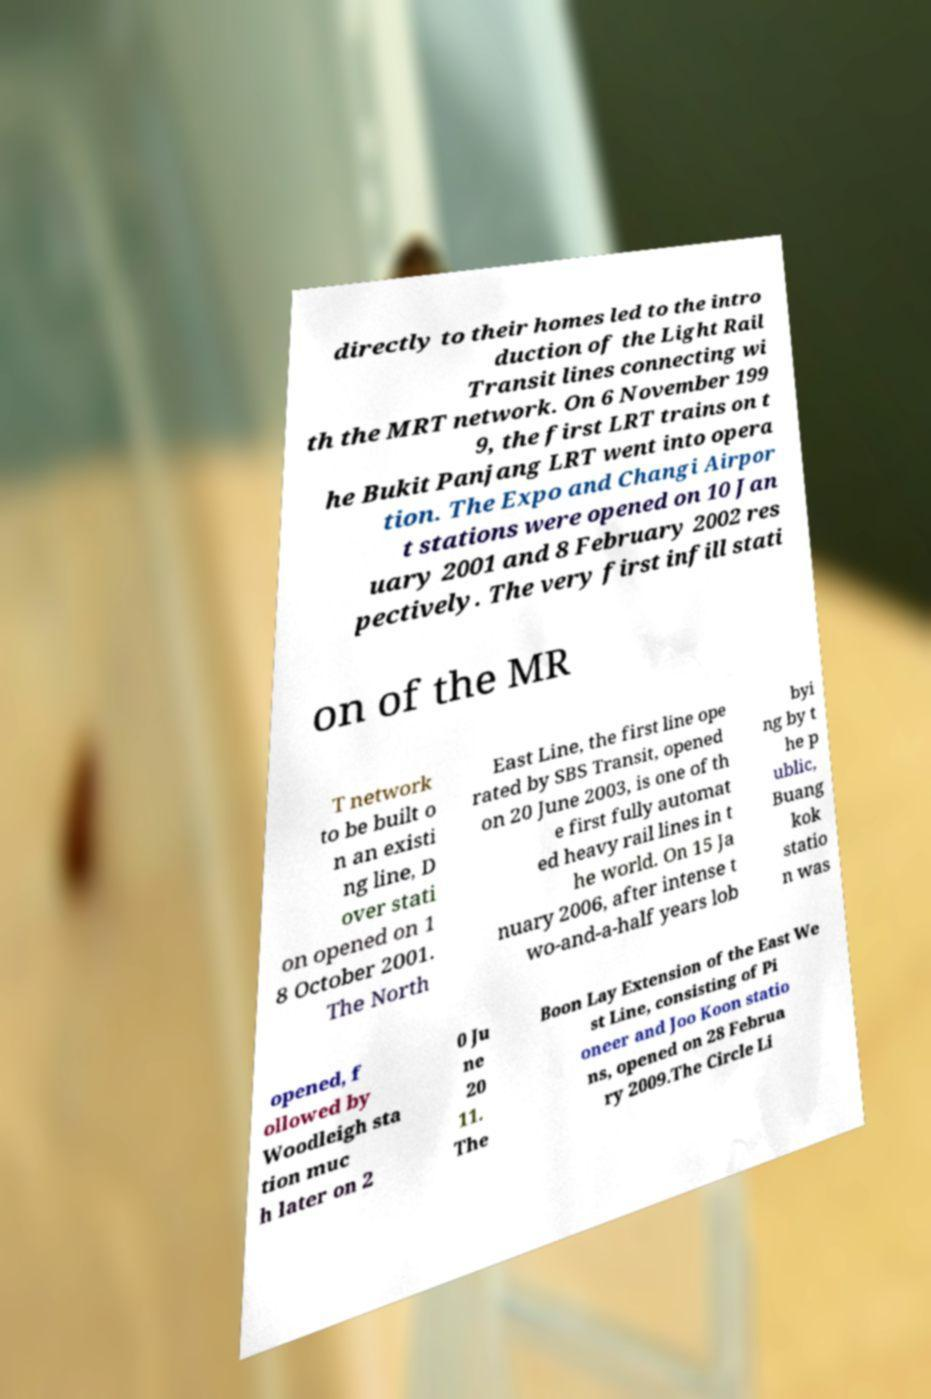I need the written content from this picture converted into text. Can you do that? directly to their homes led to the intro duction of the Light Rail Transit lines connecting wi th the MRT network. On 6 November 199 9, the first LRT trains on t he Bukit Panjang LRT went into opera tion. The Expo and Changi Airpor t stations were opened on 10 Jan uary 2001 and 8 February 2002 res pectively. The very first infill stati on of the MR T network to be built o n an existi ng line, D over stati on opened on 1 8 October 2001. The North East Line, the first line ope rated by SBS Transit, opened on 20 June 2003, is one of th e first fully automat ed heavy rail lines in t he world. On 15 Ja nuary 2006, after intense t wo-and-a-half years lob byi ng by t he p ublic, Buang kok statio n was opened, f ollowed by Woodleigh sta tion muc h later on 2 0 Ju ne 20 11. The Boon Lay Extension of the East We st Line, consisting of Pi oneer and Joo Koon statio ns, opened on 28 Februa ry 2009.The Circle Li 